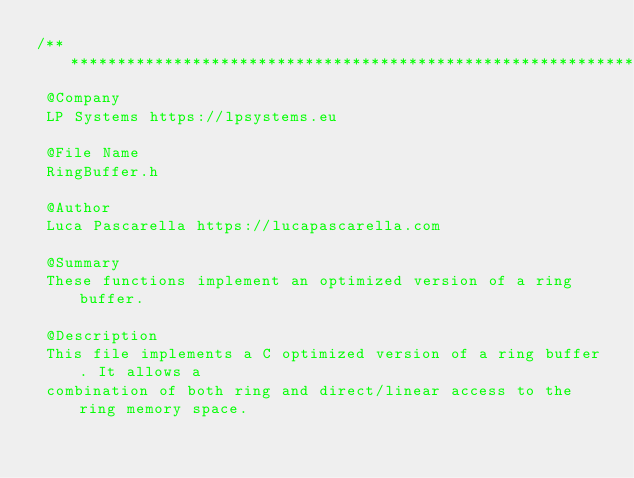<code> <loc_0><loc_0><loc_500><loc_500><_C_>/** **************************************************************************
 @Company
 LP Systems https://lpsystems.eu
 
 @File Name
 RingBuffer.h
 
 @Author
 Luca Pascarella https://lucapascarella.com
 
 @Summary
 These functions implement an optimized version of a ring buffer.
 
 @Description
 This file implements a C optimized version of a ring buffer. It allows a
 combination of both ring and direct/linear access to the ring memory space.</code> 